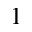<formula> <loc_0><loc_0><loc_500><loc_500>_ { 1 }</formula> 